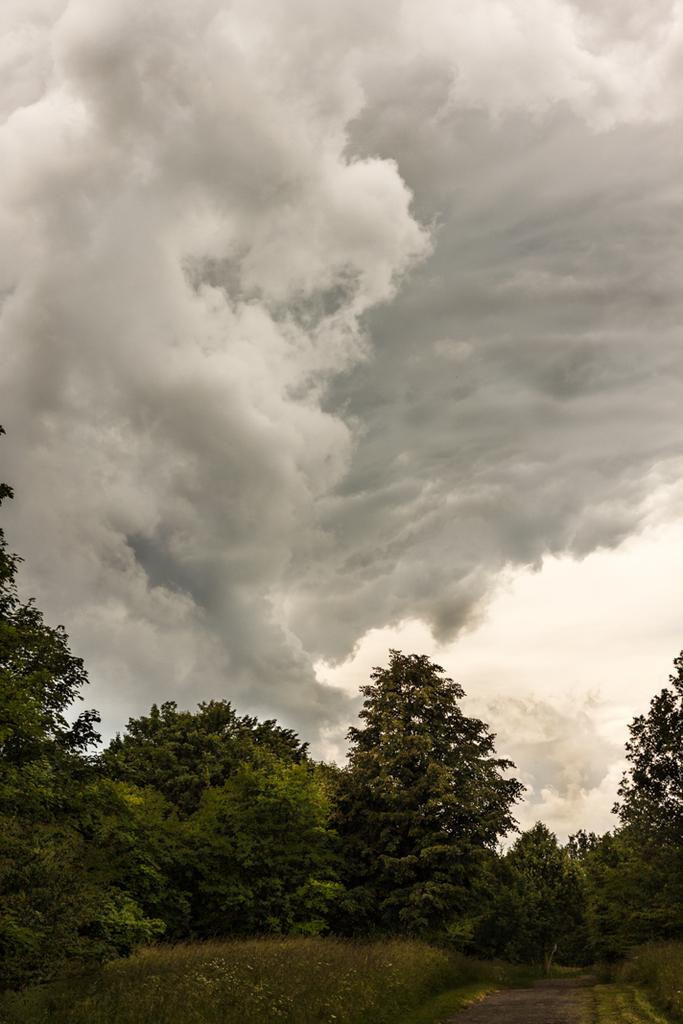What type of vegetation can be seen in the image? There are trees with branches and leaves in the image. What is the ground covered with in the image? There is grass visible in the image. What can be seen at the bottom of the image? There is a pathway at the bottom of the image. What is visible in the sky in the image? Clouds are present in the sky in the image. What type of tin can be seen covering the trees in the image? There is no tin present in the image, and the trees are not covered. How does the wheel help the grass grow in the image? There is no wheel present in the image, and the grass is not being affected by any wheel. 